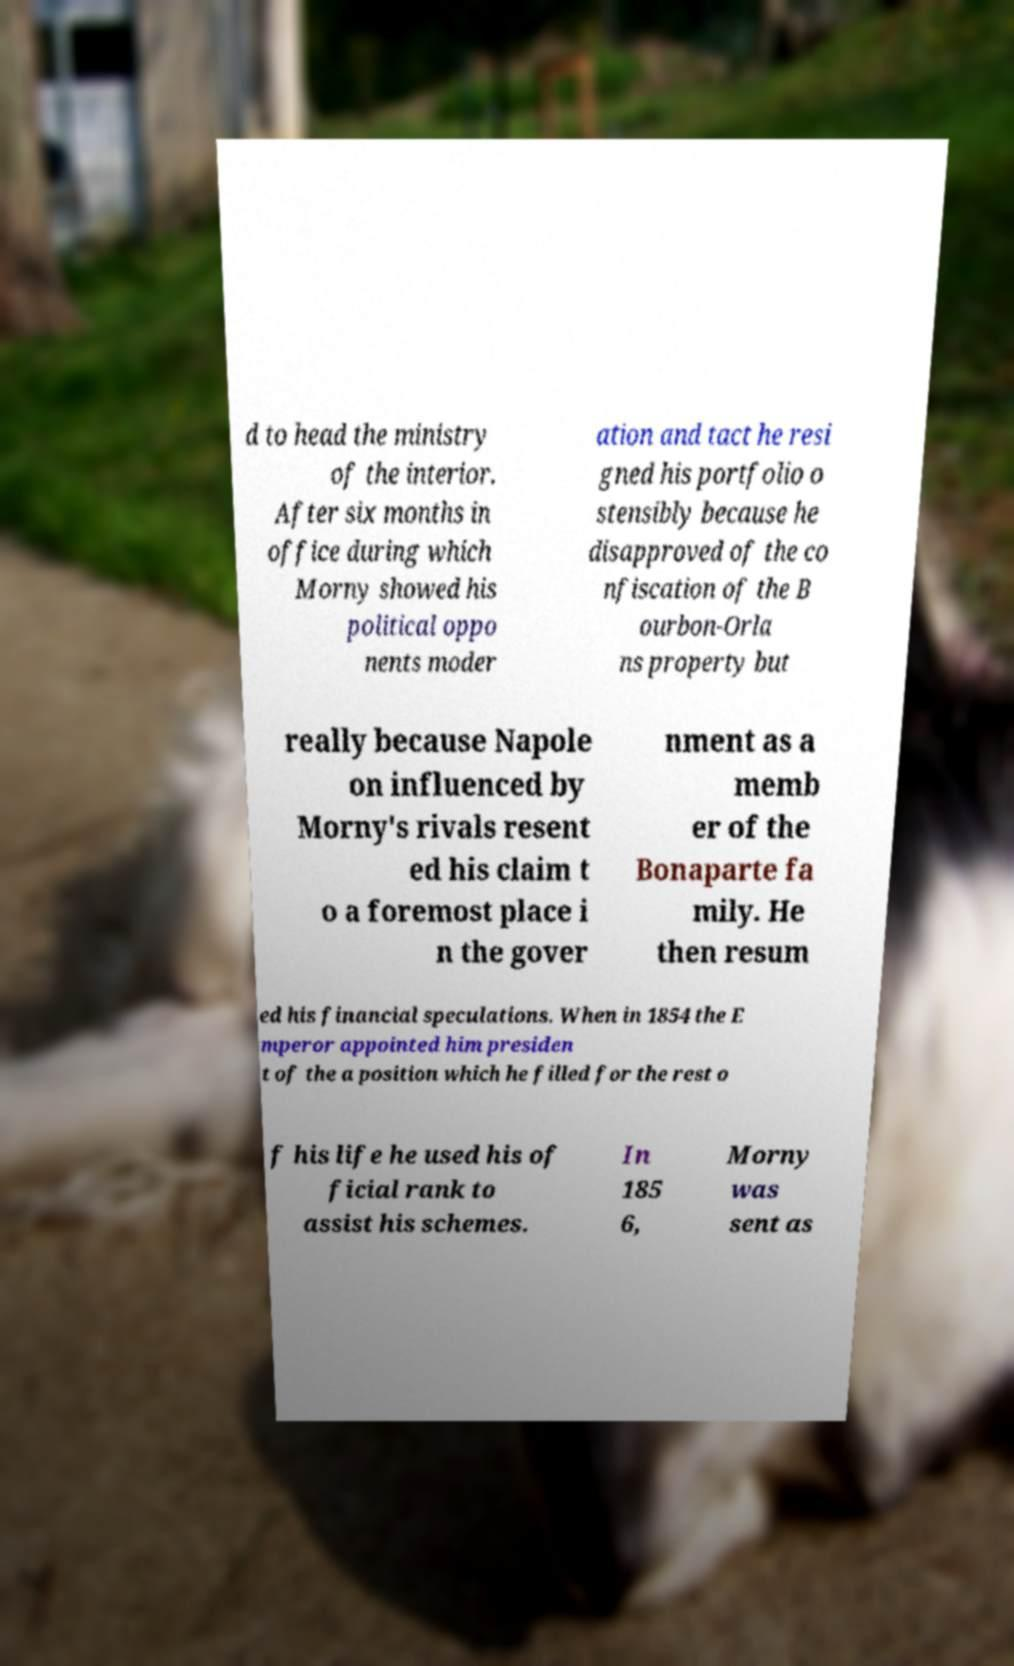Can you accurately transcribe the text from the provided image for me? d to head the ministry of the interior. After six months in office during which Morny showed his political oppo nents moder ation and tact he resi gned his portfolio o stensibly because he disapproved of the co nfiscation of the B ourbon-Orla ns property but really because Napole on influenced by Morny's rivals resent ed his claim t o a foremost place i n the gover nment as a memb er of the Bonaparte fa mily. He then resum ed his financial speculations. When in 1854 the E mperor appointed him presiden t of the a position which he filled for the rest o f his life he used his of ficial rank to assist his schemes. In 185 6, Morny was sent as 